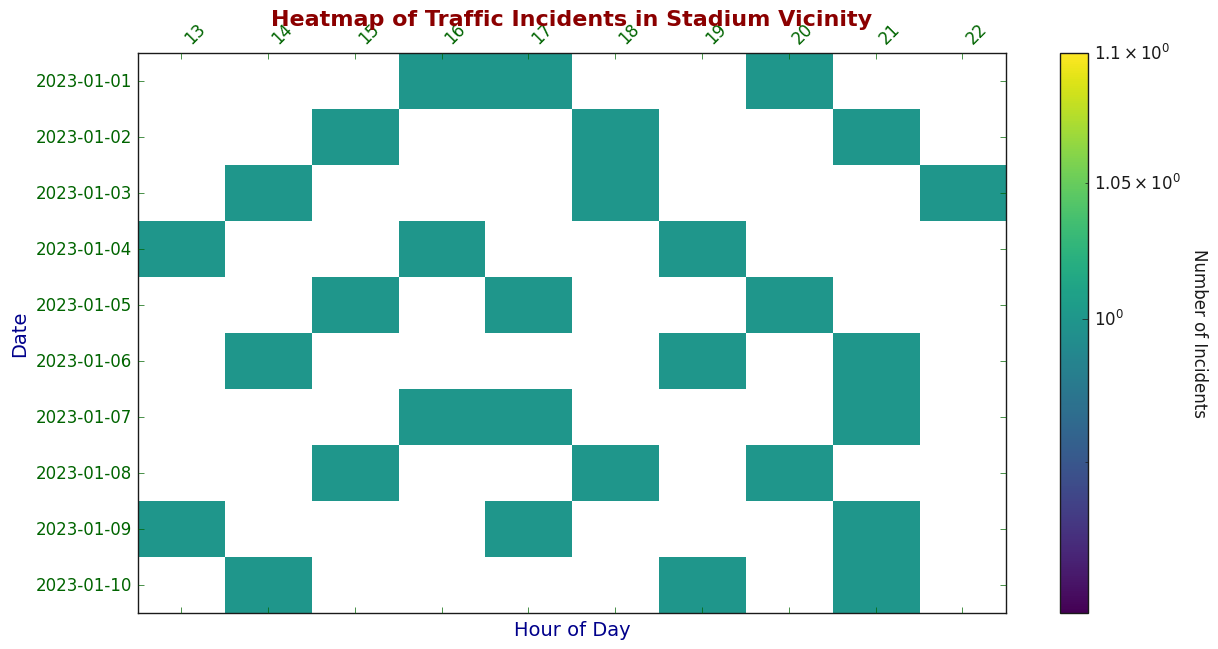What's the highest number of traffic incidents reported during a single hour of the day? Look at the color intensity during different hours in the heatmap. The darkest color represents the maximum number of incidents, which appears to be during one of the evening hours.
Answer: The highest number of incidents reported during a single hour is at 21:00 What is the total number of incidents reported on January 1, 2023? Locate the row corresponding to January 1, 2023, and sum up the values for each hour in that row.
Answer: 3 incidents During which hour of the day does the least number of traffic incidents occur on average? Compare the color intensity across the columns (hours). The lightest color represents the least number of incidents averaged across the days.
Answer: 13:00 Which day had the most traffic incidents reported, and how many were there? Find the row with the darkest overall shading and sum up the incidents for that day. January 7 has the most incidents with darker shaded cells indicating multiple incidents during different hours.
Answer: January 7, 3 incidents How do traffic incidents reported at 16:00 compare to those at 21:00 across all days? Compare the color intensity in the columns for 16:00 and 21:00. The color at 21:00 is generally darker, indicating more incidents compared to 16:00.
Answer: 21:00 has more incidents How does the number of incidents at 18:00 on January 3 compare to January 8? Look at the specific intersections of the 'Day' and 'Hour' for January 3 at 18:00 and January 8 at 18:00. The colors at these points indicate the number of incidents.
Answer: January 8 has more incidents at 18:00 What is the overall trend of traffic incidents before 16:00 compared to after 16:00? Observe the average color intensity before 16:00 and after 16:00. After 16:00, the color intensity is generally darker, suggesting more incidents.
Answer: More incidents after 16:00 